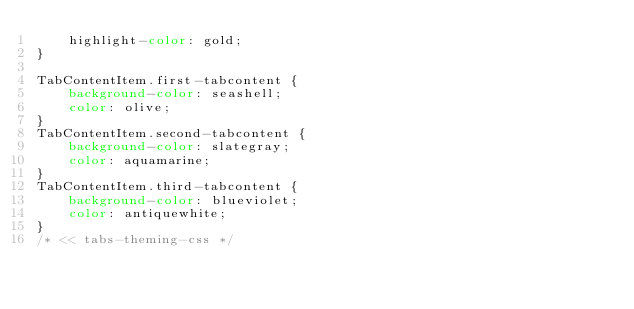Convert code to text. <code><loc_0><loc_0><loc_500><loc_500><_CSS_>    highlight-color: gold;
}

TabContentItem.first-tabcontent {
    background-color: seashell;
    color: olive;
}
TabContentItem.second-tabcontent {
    background-color: slategray;
    color: aquamarine;
}
TabContentItem.third-tabcontent {
    background-color: blueviolet;
    color: antiquewhite;
}
/* << tabs-theming-css */</code> 